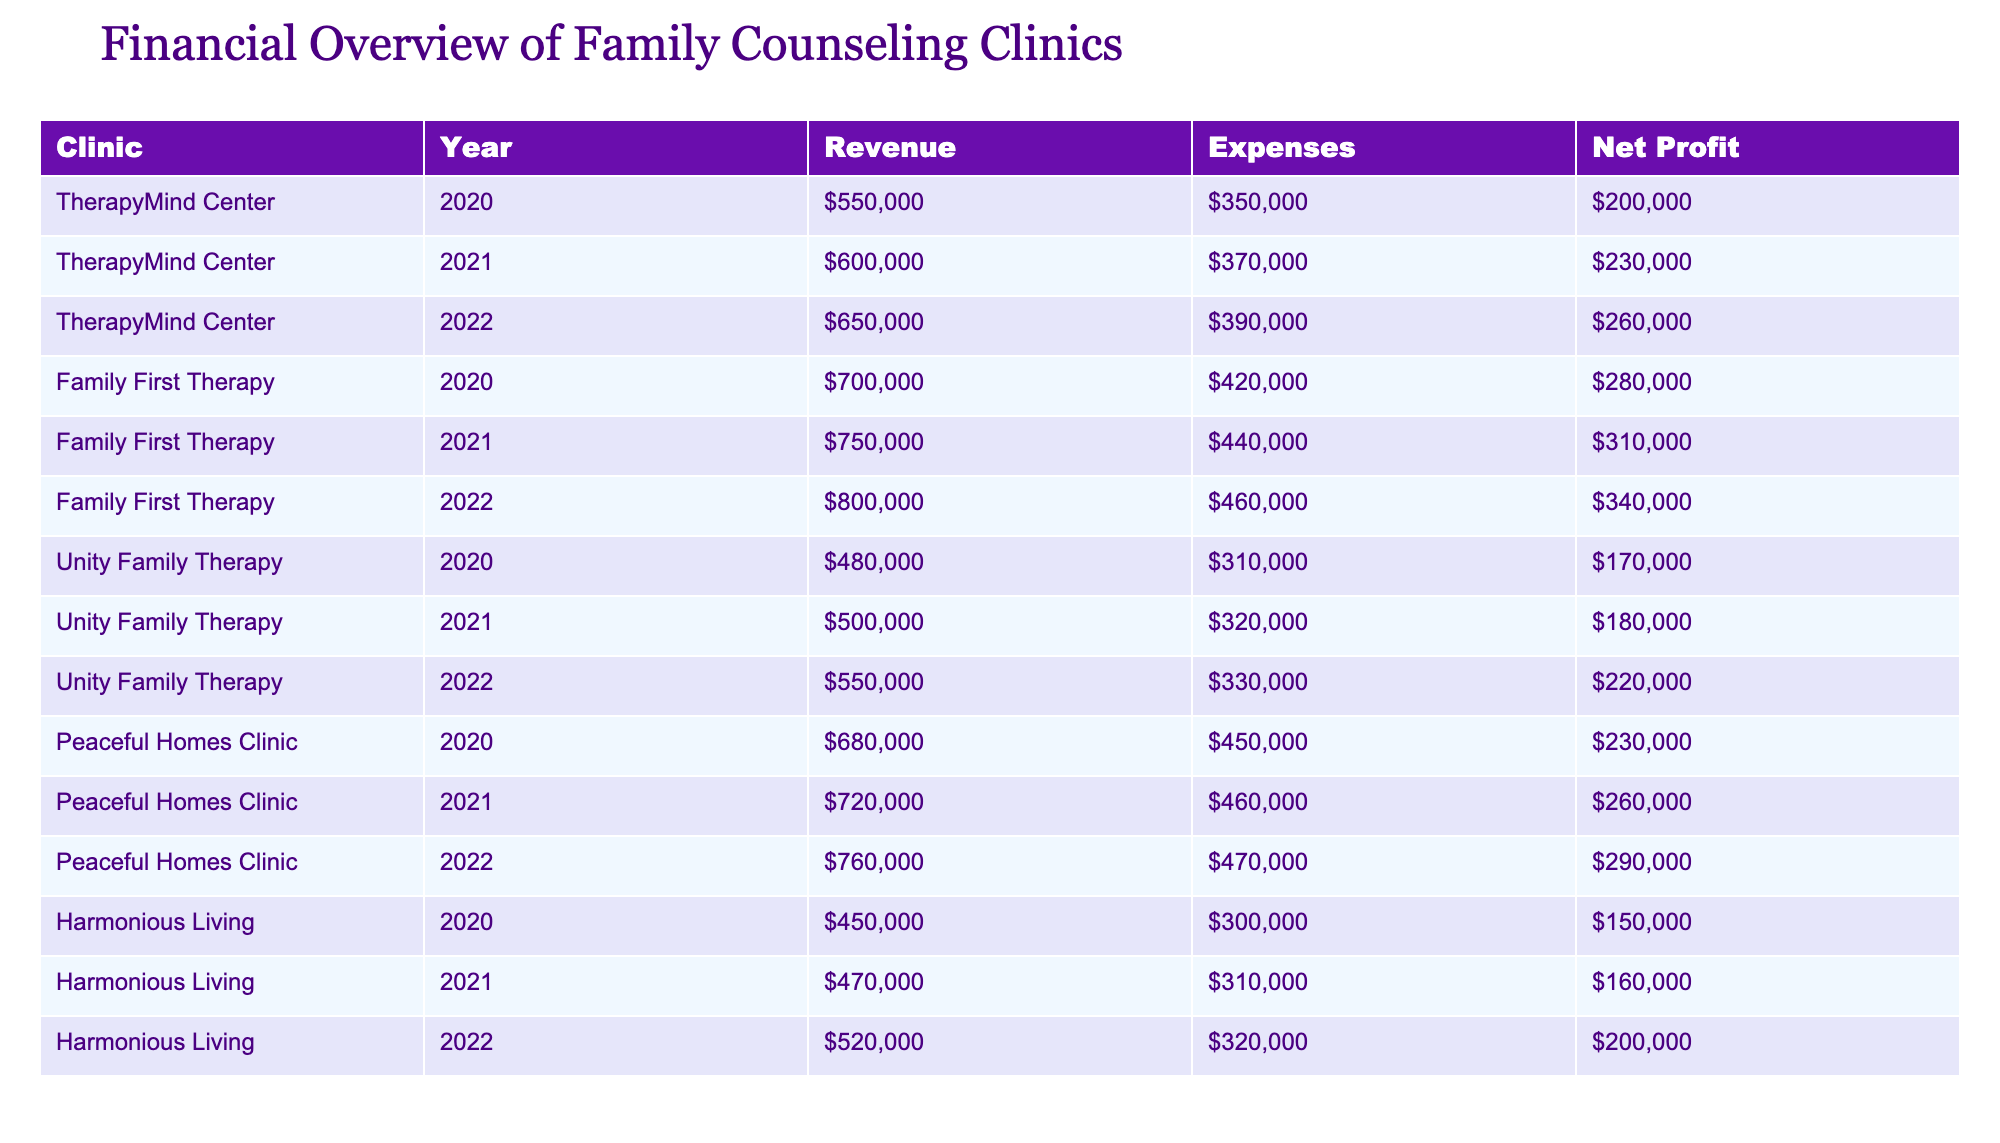What was the net profit of Family First Therapy in 2021? In the table, I locate Family First Therapy and find the year 2021. The corresponding net profit listed for that year is 310,000.
Answer: 310000 What clinic had the highest revenue in 2022? I analyze the revenues for each clinic in 2022. Family First Therapy has the highest revenue at 800,000.
Answer: Family First Therapy Calculate the average net profit for the TherapyMind Center from 2020 to 2022. I find the net profit values for TherapyMind Center over the three years: 200,000 (2020), 230,000 (2021), and 260,000 (2022). I sum these profits: 200,000 + 230,000 + 260,000 = 690,000. To find the average, I divide by the number of years (3): 690,000 / 3 = 230,000.
Answer: 230000 Did any clinic experience a decrease in net profit from 2020 to 2022? I check the net profit for each clinic for the years 2020, 2021, and 2022. For instance, Unity Family Therapy had profits of 170,000 in 2020, 180,000 in 2021, and then increased to 220,000 in 2022. By reviewing the profits, I see that all clinics either maintained or increased their net profits across these years.
Answer: No What was the total revenue generated by Peaceful Homes Clinic from 2020 to 2022? I extract the revenue figures for Peaceful Homes Clinic for the years in question: 680,000 (2020), 720,000 (2021), and 760,000 (2022). I sum them up: 680,000 + 720,000 + 760,000 = 2,160,000.
Answer: 2160000 